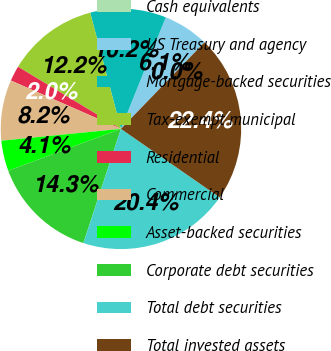Convert chart. <chart><loc_0><loc_0><loc_500><loc_500><pie_chart><fcel>Cash equivalents<fcel>US Treasury and agency<fcel>Mortgage-backed securities<fcel>Tax-exempt municipal<fcel>Residential<fcel>Commercial<fcel>Asset-backed securities<fcel>Corporate debt securities<fcel>Total debt securities<fcel>Total invested assets<nl><fcel>0.01%<fcel>6.13%<fcel>10.2%<fcel>12.24%<fcel>2.05%<fcel>8.16%<fcel>4.09%<fcel>14.28%<fcel>20.4%<fcel>22.44%<nl></chart> 